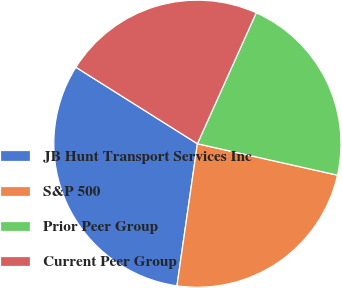<chart> <loc_0><loc_0><loc_500><loc_500><pie_chart><fcel>JB Hunt Transport Services Inc<fcel>S&P 500<fcel>Prior Peer Group<fcel>Current Peer Group<nl><fcel>31.67%<fcel>23.76%<fcel>21.79%<fcel>22.78%<nl></chart> 